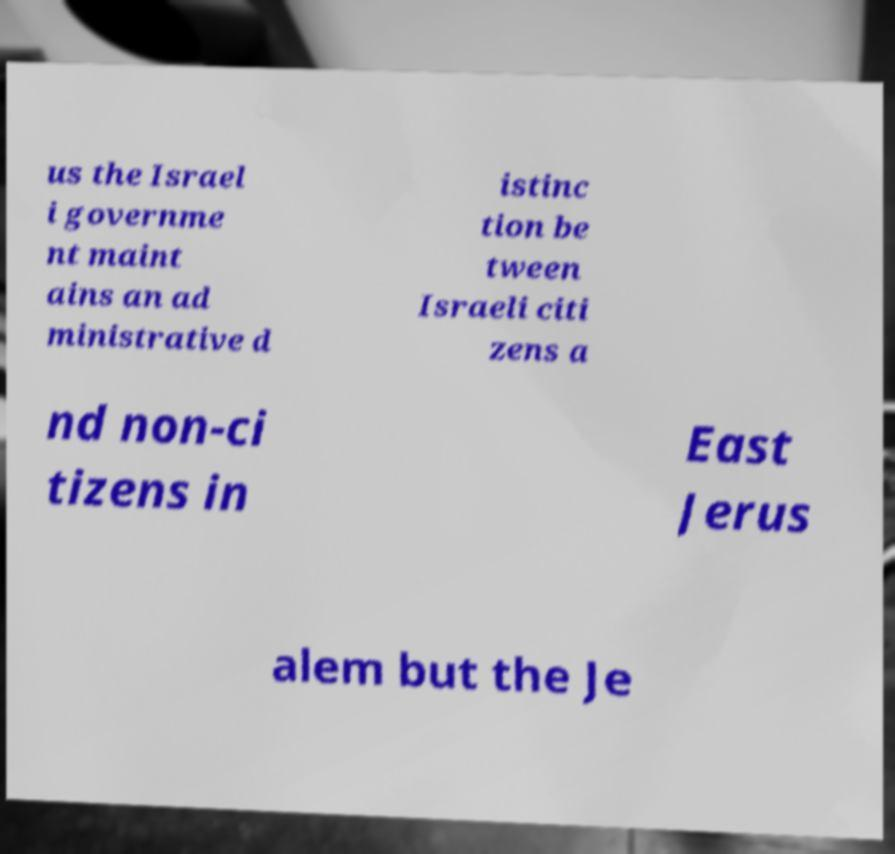Can you accurately transcribe the text from the provided image for me? us the Israel i governme nt maint ains an ad ministrative d istinc tion be tween Israeli citi zens a nd non-ci tizens in East Jerus alem but the Je 